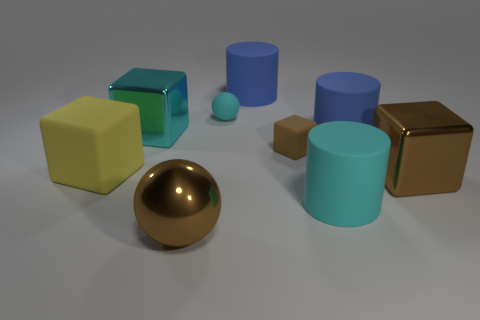Subtract all big rubber cubes. How many cubes are left? 3 Subtract all yellow cubes. How many cubes are left? 3 Subtract 1 spheres. How many spheres are left? 1 Add 1 rubber cubes. How many objects exist? 10 Subtract all cylinders. How many objects are left? 6 Subtract 0 blue balls. How many objects are left? 9 Subtract all red blocks. Subtract all cyan balls. How many blocks are left? 4 Subtract all purple cylinders. How many yellow spheres are left? 0 Subtract all big things. Subtract all green balls. How many objects are left? 2 Add 1 blue cylinders. How many blue cylinders are left? 3 